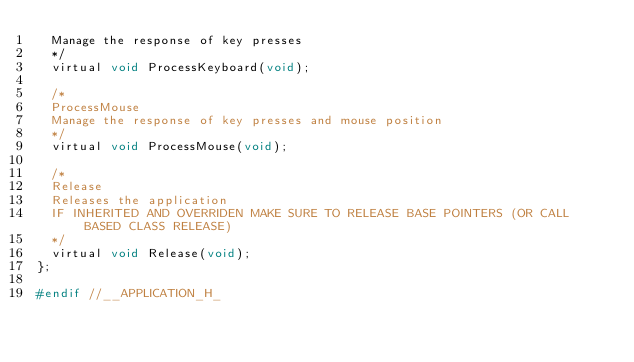<code> <loc_0><loc_0><loc_500><loc_500><_C_>	Manage the response of key presses
	*/
	virtual void ProcessKeyboard(void);

	/*
	ProcessMouse
	Manage the response of key presses and mouse position
	*/
	virtual void ProcessMouse(void);

	/*
	Release
	Releases the application
	IF INHERITED AND OVERRIDEN MAKE SURE TO RELEASE BASE POINTERS (OR CALL BASED CLASS RELEASE)
	*/
	virtual void Release(void);
};

#endif //__APPLICATION_H_
</code> 